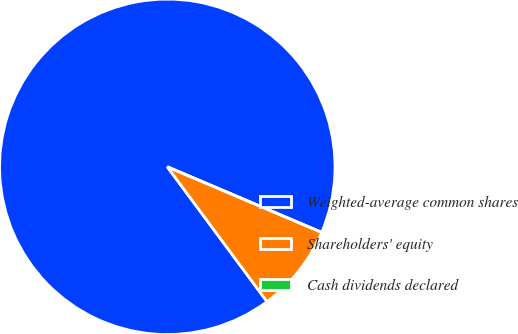<chart> <loc_0><loc_0><loc_500><loc_500><pie_chart><fcel>Weighted-average common shares<fcel>Shareholders' equity<fcel>Cash dividends declared<nl><fcel>91.53%<fcel>8.47%<fcel>0.0%<nl></chart> 